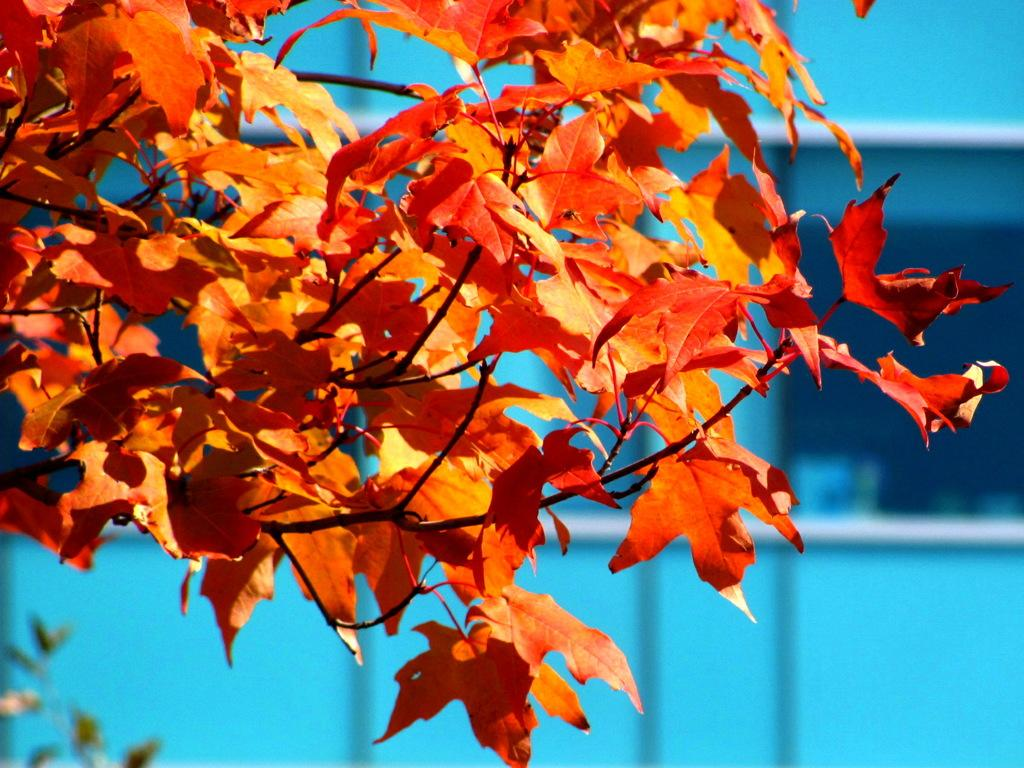What is the main subject of the image? The main subject of the image is a tree. What colors are present in the flowers of the tree? The flowers of the tree have orange and red colors. What color is the background of the image? The background of the image is blue. What societal issue is being addressed in the image? There is no societal issue being addressed in the image; it simply features a tree with orange and red flowers against a blue background. 